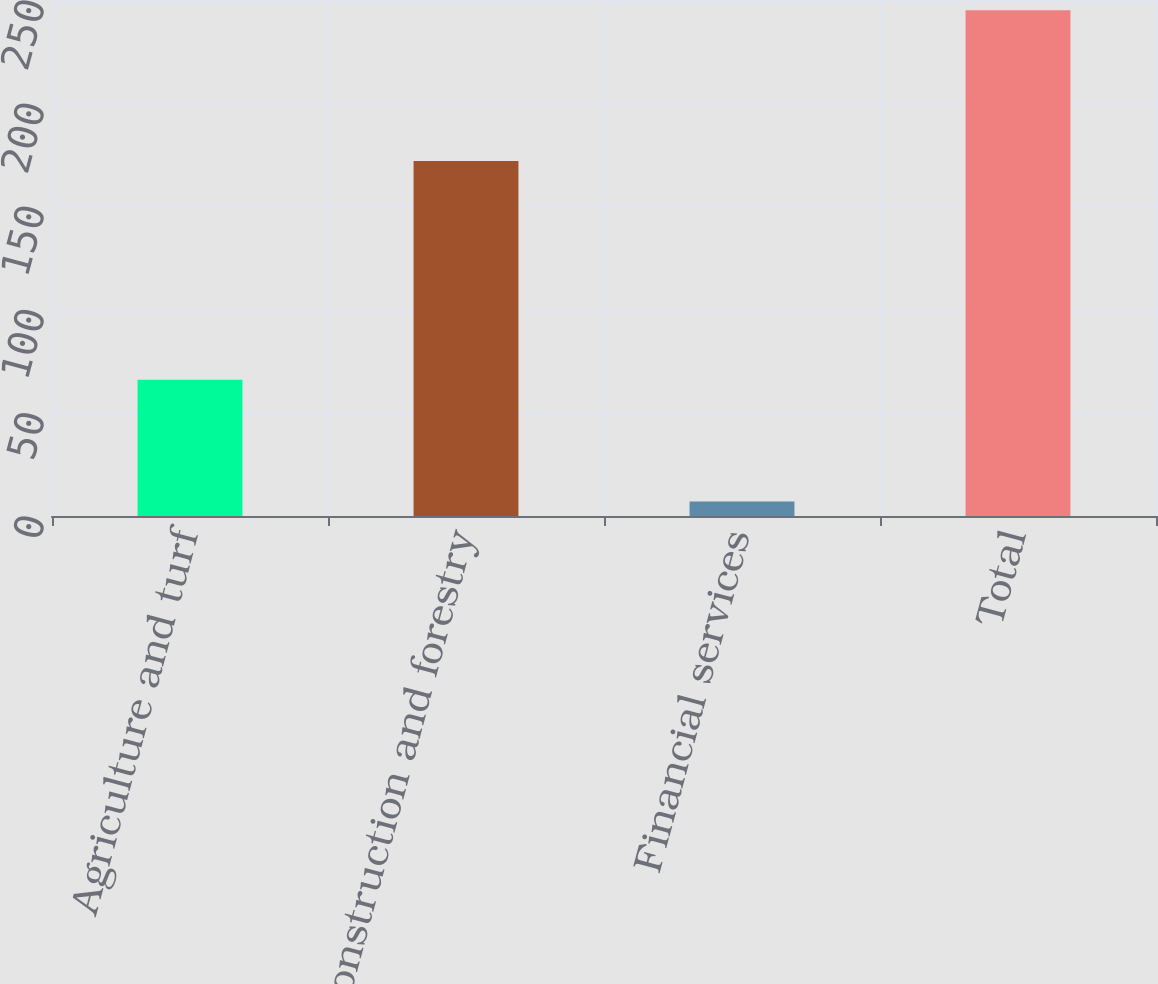Convert chart. <chart><loc_0><loc_0><loc_500><loc_500><bar_chart><fcel>Agriculture and turf<fcel>Construction and forestry<fcel>Financial services<fcel>Total<nl><fcel>66<fcel>172<fcel>7<fcel>245<nl></chart> 